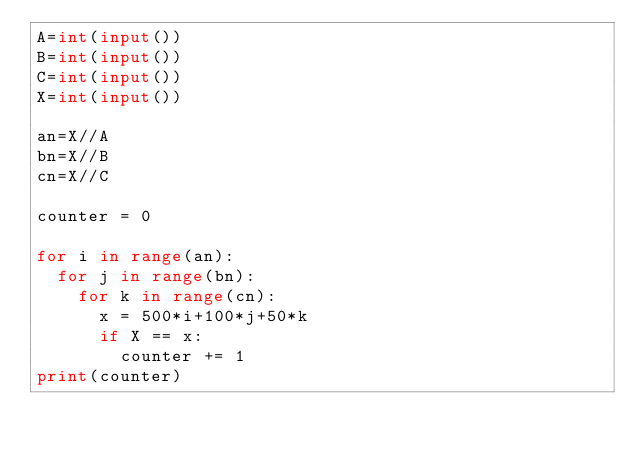<code> <loc_0><loc_0><loc_500><loc_500><_Python_>A=int(input())
B=int(input())
C=int(input())
X=int(input())
 
an=X//A
bn=X//B
cn=X//C
 
counter = 0
 
for i in range(an):
  for j in range(bn):
    for k in range(cn):
      x = 500*i+100*j+50*k
      if X == x:
        counter += 1
print(counter)</code> 